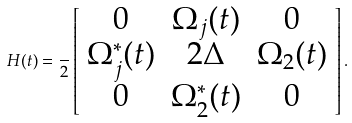<formula> <loc_0><loc_0><loc_500><loc_500>H ( t ) = \frac { } { 2 } \left [ \begin{array} { c c c } 0 & \Omega _ { j } ( t ) & 0 \\ \Omega ^ { \ast } _ { j } ( t ) & 2 \Delta & \Omega _ { 2 } ( t ) \\ 0 & \Omega _ { 2 } ^ { \ast } ( t ) & 0 \end{array} \right ] .</formula> 